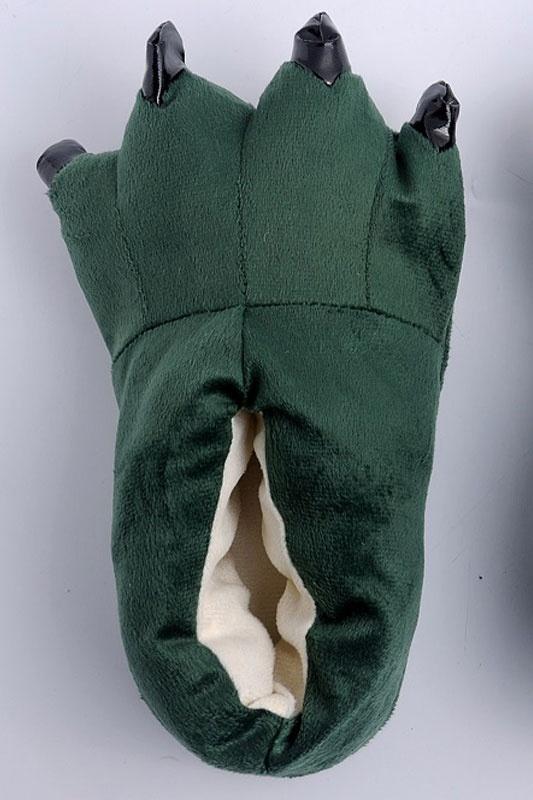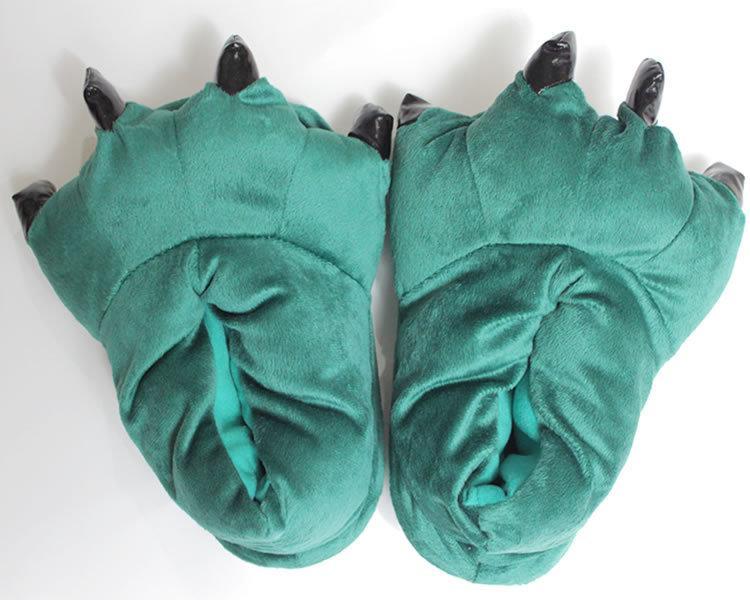The first image is the image on the left, the second image is the image on the right. Examine the images to the left and right. Is the description "All slippers are solid colors and have four claws that project outward, but only the right image shows a matched pair of slippers." accurate? Answer yes or no. Yes. The first image is the image on the left, the second image is the image on the right. Evaluate the accuracy of this statement regarding the images: "Three or more slippers in two or more colors resemble animal feet, with plastic toenails protruding from the end of each slipper.". Is it true? Answer yes or no. Yes. 